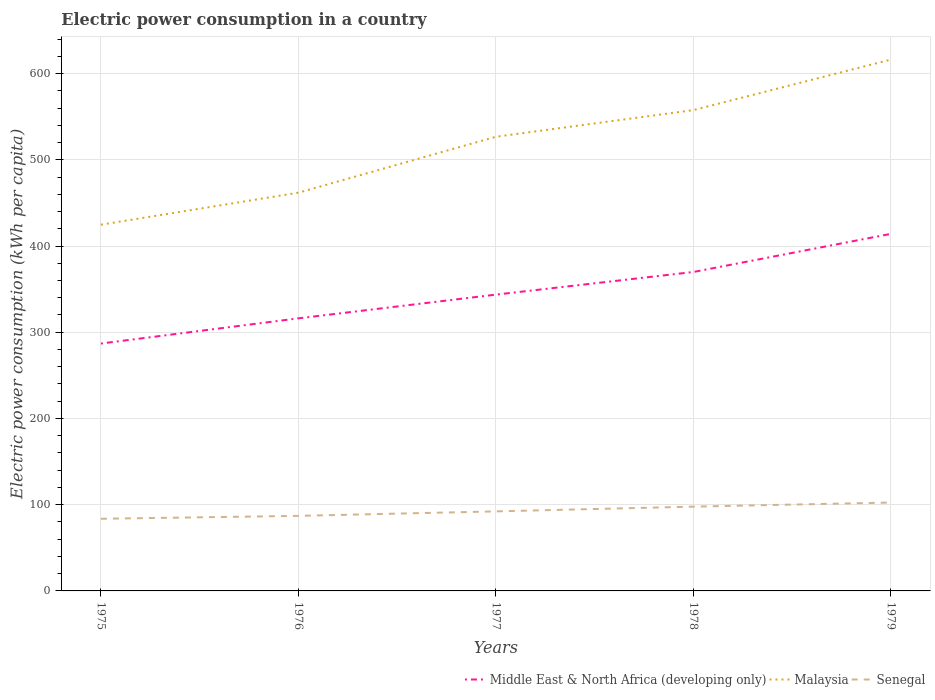How many different coloured lines are there?
Provide a short and direct response. 3. Across all years, what is the maximum electric power consumption in in Middle East & North Africa (developing only)?
Provide a short and direct response. 286.89. In which year was the electric power consumption in in Middle East & North Africa (developing only) maximum?
Provide a short and direct response. 1975. What is the total electric power consumption in in Middle East & North Africa (developing only) in the graph?
Your answer should be very brief. -70.48. What is the difference between the highest and the second highest electric power consumption in in Malaysia?
Ensure brevity in your answer.  191.53. How are the legend labels stacked?
Your answer should be very brief. Horizontal. What is the title of the graph?
Your answer should be very brief. Electric power consumption in a country. Does "Mali" appear as one of the legend labels in the graph?
Provide a succinct answer. No. What is the label or title of the X-axis?
Offer a terse response. Years. What is the label or title of the Y-axis?
Offer a very short reply. Electric power consumption (kWh per capita). What is the Electric power consumption (kWh per capita) in Middle East & North Africa (developing only) in 1975?
Ensure brevity in your answer.  286.89. What is the Electric power consumption (kWh per capita) of Malaysia in 1975?
Your answer should be very brief. 424.72. What is the Electric power consumption (kWh per capita) in Senegal in 1975?
Your answer should be very brief. 83.67. What is the Electric power consumption (kWh per capita) in Middle East & North Africa (developing only) in 1976?
Provide a short and direct response. 316.11. What is the Electric power consumption (kWh per capita) of Malaysia in 1976?
Your response must be concise. 461.84. What is the Electric power consumption (kWh per capita) of Senegal in 1976?
Offer a very short reply. 87.05. What is the Electric power consumption (kWh per capita) in Middle East & North Africa (developing only) in 1977?
Provide a succinct answer. 343.64. What is the Electric power consumption (kWh per capita) in Malaysia in 1977?
Provide a short and direct response. 526.69. What is the Electric power consumption (kWh per capita) of Senegal in 1977?
Your answer should be very brief. 92.24. What is the Electric power consumption (kWh per capita) in Middle East & North Africa (developing only) in 1978?
Ensure brevity in your answer.  369.88. What is the Electric power consumption (kWh per capita) in Malaysia in 1978?
Your response must be concise. 557.62. What is the Electric power consumption (kWh per capita) of Senegal in 1978?
Provide a succinct answer. 97.74. What is the Electric power consumption (kWh per capita) of Middle East & North Africa (developing only) in 1979?
Provide a succinct answer. 414.11. What is the Electric power consumption (kWh per capita) in Malaysia in 1979?
Your answer should be very brief. 616.24. What is the Electric power consumption (kWh per capita) in Senegal in 1979?
Provide a short and direct response. 102.5. Across all years, what is the maximum Electric power consumption (kWh per capita) in Middle East & North Africa (developing only)?
Offer a very short reply. 414.11. Across all years, what is the maximum Electric power consumption (kWh per capita) in Malaysia?
Your answer should be very brief. 616.24. Across all years, what is the maximum Electric power consumption (kWh per capita) of Senegal?
Provide a succinct answer. 102.5. Across all years, what is the minimum Electric power consumption (kWh per capita) in Middle East & North Africa (developing only)?
Provide a short and direct response. 286.89. Across all years, what is the minimum Electric power consumption (kWh per capita) in Malaysia?
Your answer should be very brief. 424.72. Across all years, what is the minimum Electric power consumption (kWh per capita) in Senegal?
Provide a short and direct response. 83.67. What is the total Electric power consumption (kWh per capita) of Middle East & North Africa (developing only) in the graph?
Offer a terse response. 1730.62. What is the total Electric power consumption (kWh per capita) of Malaysia in the graph?
Ensure brevity in your answer.  2587.11. What is the total Electric power consumption (kWh per capita) in Senegal in the graph?
Offer a terse response. 463.2. What is the difference between the Electric power consumption (kWh per capita) of Middle East & North Africa (developing only) in 1975 and that in 1976?
Give a very brief answer. -29.22. What is the difference between the Electric power consumption (kWh per capita) of Malaysia in 1975 and that in 1976?
Your answer should be very brief. -37.12. What is the difference between the Electric power consumption (kWh per capita) in Senegal in 1975 and that in 1976?
Your answer should be compact. -3.38. What is the difference between the Electric power consumption (kWh per capita) of Middle East & North Africa (developing only) in 1975 and that in 1977?
Make the answer very short. -56.75. What is the difference between the Electric power consumption (kWh per capita) in Malaysia in 1975 and that in 1977?
Offer a terse response. -101.98. What is the difference between the Electric power consumption (kWh per capita) of Senegal in 1975 and that in 1977?
Make the answer very short. -8.58. What is the difference between the Electric power consumption (kWh per capita) of Middle East & North Africa (developing only) in 1975 and that in 1978?
Ensure brevity in your answer.  -83. What is the difference between the Electric power consumption (kWh per capita) in Malaysia in 1975 and that in 1978?
Your response must be concise. -132.91. What is the difference between the Electric power consumption (kWh per capita) of Senegal in 1975 and that in 1978?
Offer a very short reply. -14.08. What is the difference between the Electric power consumption (kWh per capita) in Middle East & North Africa (developing only) in 1975 and that in 1979?
Keep it short and to the point. -127.23. What is the difference between the Electric power consumption (kWh per capita) in Malaysia in 1975 and that in 1979?
Your answer should be very brief. -191.53. What is the difference between the Electric power consumption (kWh per capita) of Senegal in 1975 and that in 1979?
Offer a terse response. -18.84. What is the difference between the Electric power consumption (kWh per capita) of Middle East & North Africa (developing only) in 1976 and that in 1977?
Offer a very short reply. -27.53. What is the difference between the Electric power consumption (kWh per capita) of Malaysia in 1976 and that in 1977?
Keep it short and to the point. -64.86. What is the difference between the Electric power consumption (kWh per capita) in Senegal in 1976 and that in 1977?
Offer a very short reply. -5.2. What is the difference between the Electric power consumption (kWh per capita) in Middle East & North Africa (developing only) in 1976 and that in 1978?
Provide a succinct answer. -53.78. What is the difference between the Electric power consumption (kWh per capita) in Malaysia in 1976 and that in 1978?
Your answer should be very brief. -95.79. What is the difference between the Electric power consumption (kWh per capita) in Senegal in 1976 and that in 1978?
Provide a succinct answer. -10.7. What is the difference between the Electric power consumption (kWh per capita) of Middle East & North Africa (developing only) in 1976 and that in 1979?
Make the answer very short. -98. What is the difference between the Electric power consumption (kWh per capita) in Malaysia in 1976 and that in 1979?
Your answer should be compact. -154.4. What is the difference between the Electric power consumption (kWh per capita) in Senegal in 1976 and that in 1979?
Offer a terse response. -15.46. What is the difference between the Electric power consumption (kWh per capita) of Middle East & North Africa (developing only) in 1977 and that in 1978?
Provide a succinct answer. -26.25. What is the difference between the Electric power consumption (kWh per capita) in Malaysia in 1977 and that in 1978?
Your answer should be compact. -30.93. What is the difference between the Electric power consumption (kWh per capita) in Senegal in 1977 and that in 1978?
Offer a terse response. -5.5. What is the difference between the Electric power consumption (kWh per capita) of Middle East & North Africa (developing only) in 1977 and that in 1979?
Keep it short and to the point. -70.48. What is the difference between the Electric power consumption (kWh per capita) in Malaysia in 1977 and that in 1979?
Keep it short and to the point. -89.55. What is the difference between the Electric power consumption (kWh per capita) of Senegal in 1977 and that in 1979?
Give a very brief answer. -10.26. What is the difference between the Electric power consumption (kWh per capita) of Middle East & North Africa (developing only) in 1978 and that in 1979?
Provide a short and direct response. -44.23. What is the difference between the Electric power consumption (kWh per capita) of Malaysia in 1978 and that in 1979?
Give a very brief answer. -58.62. What is the difference between the Electric power consumption (kWh per capita) in Senegal in 1978 and that in 1979?
Make the answer very short. -4.76. What is the difference between the Electric power consumption (kWh per capita) in Middle East & North Africa (developing only) in 1975 and the Electric power consumption (kWh per capita) in Malaysia in 1976?
Your answer should be compact. -174.95. What is the difference between the Electric power consumption (kWh per capita) in Middle East & North Africa (developing only) in 1975 and the Electric power consumption (kWh per capita) in Senegal in 1976?
Keep it short and to the point. 199.84. What is the difference between the Electric power consumption (kWh per capita) in Malaysia in 1975 and the Electric power consumption (kWh per capita) in Senegal in 1976?
Ensure brevity in your answer.  337.67. What is the difference between the Electric power consumption (kWh per capita) in Middle East & North Africa (developing only) in 1975 and the Electric power consumption (kWh per capita) in Malaysia in 1977?
Give a very brief answer. -239.81. What is the difference between the Electric power consumption (kWh per capita) of Middle East & North Africa (developing only) in 1975 and the Electric power consumption (kWh per capita) of Senegal in 1977?
Ensure brevity in your answer.  194.64. What is the difference between the Electric power consumption (kWh per capita) of Malaysia in 1975 and the Electric power consumption (kWh per capita) of Senegal in 1977?
Your response must be concise. 332.47. What is the difference between the Electric power consumption (kWh per capita) in Middle East & North Africa (developing only) in 1975 and the Electric power consumption (kWh per capita) in Malaysia in 1978?
Make the answer very short. -270.74. What is the difference between the Electric power consumption (kWh per capita) of Middle East & North Africa (developing only) in 1975 and the Electric power consumption (kWh per capita) of Senegal in 1978?
Your response must be concise. 189.15. What is the difference between the Electric power consumption (kWh per capita) of Malaysia in 1975 and the Electric power consumption (kWh per capita) of Senegal in 1978?
Provide a short and direct response. 326.97. What is the difference between the Electric power consumption (kWh per capita) of Middle East & North Africa (developing only) in 1975 and the Electric power consumption (kWh per capita) of Malaysia in 1979?
Provide a short and direct response. -329.36. What is the difference between the Electric power consumption (kWh per capita) of Middle East & North Africa (developing only) in 1975 and the Electric power consumption (kWh per capita) of Senegal in 1979?
Provide a short and direct response. 184.39. What is the difference between the Electric power consumption (kWh per capita) of Malaysia in 1975 and the Electric power consumption (kWh per capita) of Senegal in 1979?
Your answer should be very brief. 322.21. What is the difference between the Electric power consumption (kWh per capita) of Middle East & North Africa (developing only) in 1976 and the Electric power consumption (kWh per capita) of Malaysia in 1977?
Offer a very short reply. -210.59. What is the difference between the Electric power consumption (kWh per capita) in Middle East & North Africa (developing only) in 1976 and the Electric power consumption (kWh per capita) in Senegal in 1977?
Keep it short and to the point. 223.86. What is the difference between the Electric power consumption (kWh per capita) of Malaysia in 1976 and the Electric power consumption (kWh per capita) of Senegal in 1977?
Provide a short and direct response. 369.6. What is the difference between the Electric power consumption (kWh per capita) of Middle East & North Africa (developing only) in 1976 and the Electric power consumption (kWh per capita) of Malaysia in 1978?
Your answer should be compact. -241.52. What is the difference between the Electric power consumption (kWh per capita) in Middle East & North Africa (developing only) in 1976 and the Electric power consumption (kWh per capita) in Senegal in 1978?
Your response must be concise. 218.37. What is the difference between the Electric power consumption (kWh per capita) of Malaysia in 1976 and the Electric power consumption (kWh per capita) of Senegal in 1978?
Give a very brief answer. 364.1. What is the difference between the Electric power consumption (kWh per capita) in Middle East & North Africa (developing only) in 1976 and the Electric power consumption (kWh per capita) in Malaysia in 1979?
Keep it short and to the point. -300.13. What is the difference between the Electric power consumption (kWh per capita) in Middle East & North Africa (developing only) in 1976 and the Electric power consumption (kWh per capita) in Senegal in 1979?
Ensure brevity in your answer.  213.61. What is the difference between the Electric power consumption (kWh per capita) in Malaysia in 1976 and the Electric power consumption (kWh per capita) in Senegal in 1979?
Offer a very short reply. 359.34. What is the difference between the Electric power consumption (kWh per capita) of Middle East & North Africa (developing only) in 1977 and the Electric power consumption (kWh per capita) of Malaysia in 1978?
Your answer should be very brief. -213.99. What is the difference between the Electric power consumption (kWh per capita) in Middle East & North Africa (developing only) in 1977 and the Electric power consumption (kWh per capita) in Senegal in 1978?
Provide a short and direct response. 245.89. What is the difference between the Electric power consumption (kWh per capita) in Malaysia in 1977 and the Electric power consumption (kWh per capita) in Senegal in 1978?
Your response must be concise. 428.95. What is the difference between the Electric power consumption (kWh per capita) of Middle East & North Africa (developing only) in 1977 and the Electric power consumption (kWh per capita) of Malaysia in 1979?
Your response must be concise. -272.61. What is the difference between the Electric power consumption (kWh per capita) in Middle East & North Africa (developing only) in 1977 and the Electric power consumption (kWh per capita) in Senegal in 1979?
Your answer should be very brief. 241.13. What is the difference between the Electric power consumption (kWh per capita) of Malaysia in 1977 and the Electric power consumption (kWh per capita) of Senegal in 1979?
Offer a terse response. 424.19. What is the difference between the Electric power consumption (kWh per capita) in Middle East & North Africa (developing only) in 1978 and the Electric power consumption (kWh per capita) in Malaysia in 1979?
Provide a short and direct response. -246.36. What is the difference between the Electric power consumption (kWh per capita) in Middle East & North Africa (developing only) in 1978 and the Electric power consumption (kWh per capita) in Senegal in 1979?
Offer a very short reply. 267.38. What is the difference between the Electric power consumption (kWh per capita) of Malaysia in 1978 and the Electric power consumption (kWh per capita) of Senegal in 1979?
Make the answer very short. 455.12. What is the average Electric power consumption (kWh per capita) of Middle East & North Africa (developing only) per year?
Provide a short and direct response. 346.12. What is the average Electric power consumption (kWh per capita) in Malaysia per year?
Provide a succinct answer. 517.42. What is the average Electric power consumption (kWh per capita) in Senegal per year?
Keep it short and to the point. 92.64. In the year 1975, what is the difference between the Electric power consumption (kWh per capita) in Middle East & North Africa (developing only) and Electric power consumption (kWh per capita) in Malaysia?
Offer a very short reply. -137.83. In the year 1975, what is the difference between the Electric power consumption (kWh per capita) of Middle East & North Africa (developing only) and Electric power consumption (kWh per capita) of Senegal?
Your answer should be very brief. 203.22. In the year 1975, what is the difference between the Electric power consumption (kWh per capita) of Malaysia and Electric power consumption (kWh per capita) of Senegal?
Offer a terse response. 341.05. In the year 1976, what is the difference between the Electric power consumption (kWh per capita) of Middle East & North Africa (developing only) and Electric power consumption (kWh per capita) of Malaysia?
Offer a very short reply. -145.73. In the year 1976, what is the difference between the Electric power consumption (kWh per capita) of Middle East & North Africa (developing only) and Electric power consumption (kWh per capita) of Senegal?
Give a very brief answer. 229.06. In the year 1976, what is the difference between the Electric power consumption (kWh per capita) in Malaysia and Electric power consumption (kWh per capita) in Senegal?
Keep it short and to the point. 374.79. In the year 1977, what is the difference between the Electric power consumption (kWh per capita) in Middle East & North Africa (developing only) and Electric power consumption (kWh per capita) in Malaysia?
Make the answer very short. -183.06. In the year 1977, what is the difference between the Electric power consumption (kWh per capita) in Middle East & North Africa (developing only) and Electric power consumption (kWh per capita) in Senegal?
Your response must be concise. 251.39. In the year 1977, what is the difference between the Electric power consumption (kWh per capita) of Malaysia and Electric power consumption (kWh per capita) of Senegal?
Keep it short and to the point. 434.45. In the year 1978, what is the difference between the Electric power consumption (kWh per capita) of Middle East & North Africa (developing only) and Electric power consumption (kWh per capita) of Malaysia?
Make the answer very short. -187.74. In the year 1978, what is the difference between the Electric power consumption (kWh per capita) in Middle East & North Africa (developing only) and Electric power consumption (kWh per capita) in Senegal?
Offer a terse response. 272.14. In the year 1978, what is the difference between the Electric power consumption (kWh per capita) of Malaysia and Electric power consumption (kWh per capita) of Senegal?
Provide a succinct answer. 459.88. In the year 1979, what is the difference between the Electric power consumption (kWh per capita) of Middle East & North Africa (developing only) and Electric power consumption (kWh per capita) of Malaysia?
Your answer should be very brief. -202.13. In the year 1979, what is the difference between the Electric power consumption (kWh per capita) of Middle East & North Africa (developing only) and Electric power consumption (kWh per capita) of Senegal?
Your response must be concise. 311.61. In the year 1979, what is the difference between the Electric power consumption (kWh per capita) of Malaysia and Electric power consumption (kWh per capita) of Senegal?
Your answer should be compact. 513.74. What is the ratio of the Electric power consumption (kWh per capita) of Middle East & North Africa (developing only) in 1975 to that in 1976?
Give a very brief answer. 0.91. What is the ratio of the Electric power consumption (kWh per capita) of Malaysia in 1975 to that in 1976?
Ensure brevity in your answer.  0.92. What is the ratio of the Electric power consumption (kWh per capita) in Senegal in 1975 to that in 1976?
Make the answer very short. 0.96. What is the ratio of the Electric power consumption (kWh per capita) of Middle East & North Africa (developing only) in 1975 to that in 1977?
Offer a terse response. 0.83. What is the ratio of the Electric power consumption (kWh per capita) of Malaysia in 1975 to that in 1977?
Provide a short and direct response. 0.81. What is the ratio of the Electric power consumption (kWh per capita) of Senegal in 1975 to that in 1977?
Make the answer very short. 0.91. What is the ratio of the Electric power consumption (kWh per capita) in Middle East & North Africa (developing only) in 1975 to that in 1978?
Your answer should be very brief. 0.78. What is the ratio of the Electric power consumption (kWh per capita) in Malaysia in 1975 to that in 1978?
Offer a terse response. 0.76. What is the ratio of the Electric power consumption (kWh per capita) in Senegal in 1975 to that in 1978?
Your response must be concise. 0.86. What is the ratio of the Electric power consumption (kWh per capita) in Middle East & North Africa (developing only) in 1975 to that in 1979?
Offer a terse response. 0.69. What is the ratio of the Electric power consumption (kWh per capita) in Malaysia in 1975 to that in 1979?
Give a very brief answer. 0.69. What is the ratio of the Electric power consumption (kWh per capita) of Senegal in 1975 to that in 1979?
Offer a terse response. 0.82. What is the ratio of the Electric power consumption (kWh per capita) of Middle East & North Africa (developing only) in 1976 to that in 1977?
Your response must be concise. 0.92. What is the ratio of the Electric power consumption (kWh per capita) in Malaysia in 1976 to that in 1977?
Your answer should be very brief. 0.88. What is the ratio of the Electric power consumption (kWh per capita) of Senegal in 1976 to that in 1977?
Provide a short and direct response. 0.94. What is the ratio of the Electric power consumption (kWh per capita) of Middle East & North Africa (developing only) in 1976 to that in 1978?
Keep it short and to the point. 0.85. What is the ratio of the Electric power consumption (kWh per capita) in Malaysia in 1976 to that in 1978?
Your response must be concise. 0.83. What is the ratio of the Electric power consumption (kWh per capita) of Senegal in 1976 to that in 1978?
Offer a terse response. 0.89. What is the ratio of the Electric power consumption (kWh per capita) of Middle East & North Africa (developing only) in 1976 to that in 1979?
Your answer should be very brief. 0.76. What is the ratio of the Electric power consumption (kWh per capita) of Malaysia in 1976 to that in 1979?
Offer a terse response. 0.75. What is the ratio of the Electric power consumption (kWh per capita) in Senegal in 1976 to that in 1979?
Offer a terse response. 0.85. What is the ratio of the Electric power consumption (kWh per capita) of Middle East & North Africa (developing only) in 1977 to that in 1978?
Provide a succinct answer. 0.93. What is the ratio of the Electric power consumption (kWh per capita) of Malaysia in 1977 to that in 1978?
Your answer should be compact. 0.94. What is the ratio of the Electric power consumption (kWh per capita) of Senegal in 1977 to that in 1978?
Offer a very short reply. 0.94. What is the ratio of the Electric power consumption (kWh per capita) of Middle East & North Africa (developing only) in 1977 to that in 1979?
Offer a very short reply. 0.83. What is the ratio of the Electric power consumption (kWh per capita) in Malaysia in 1977 to that in 1979?
Your response must be concise. 0.85. What is the ratio of the Electric power consumption (kWh per capita) of Senegal in 1977 to that in 1979?
Ensure brevity in your answer.  0.9. What is the ratio of the Electric power consumption (kWh per capita) of Middle East & North Africa (developing only) in 1978 to that in 1979?
Ensure brevity in your answer.  0.89. What is the ratio of the Electric power consumption (kWh per capita) of Malaysia in 1978 to that in 1979?
Provide a short and direct response. 0.9. What is the ratio of the Electric power consumption (kWh per capita) of Senegal in 1978 to that in 1979?
Make the answer very short. 0.95. What is the difference between the highest and the second highest Electric power consumption (kWh per capita) in Middle East & North Africa (developing only)?
Your answer should be compact. 44.23. What is the difference between the highest and the second highest Electric power consumption (kWh per capita) in Malaysia?
Your answer should be compact. 58.62. What is the difference between the highest and the second highest Electric power consumption (kWh per capita) of Senegal?
Make the answer very short. 4.76. What is the difference between the highest and the lowest Electric power consumption (kWh per capita) of Middle East & North Africa (developing only)?
Provide a succinct answer. 127.23. What is the difference between the highest and the lowest Electric power consumption (kWh per capita) in Malaysia?
Offer a very short reply. 191.53. What is the difference between the highest and the lowest Electric power consumption (kWh per capita) of Senegal?
Your answer should be very brief. 18.84. 